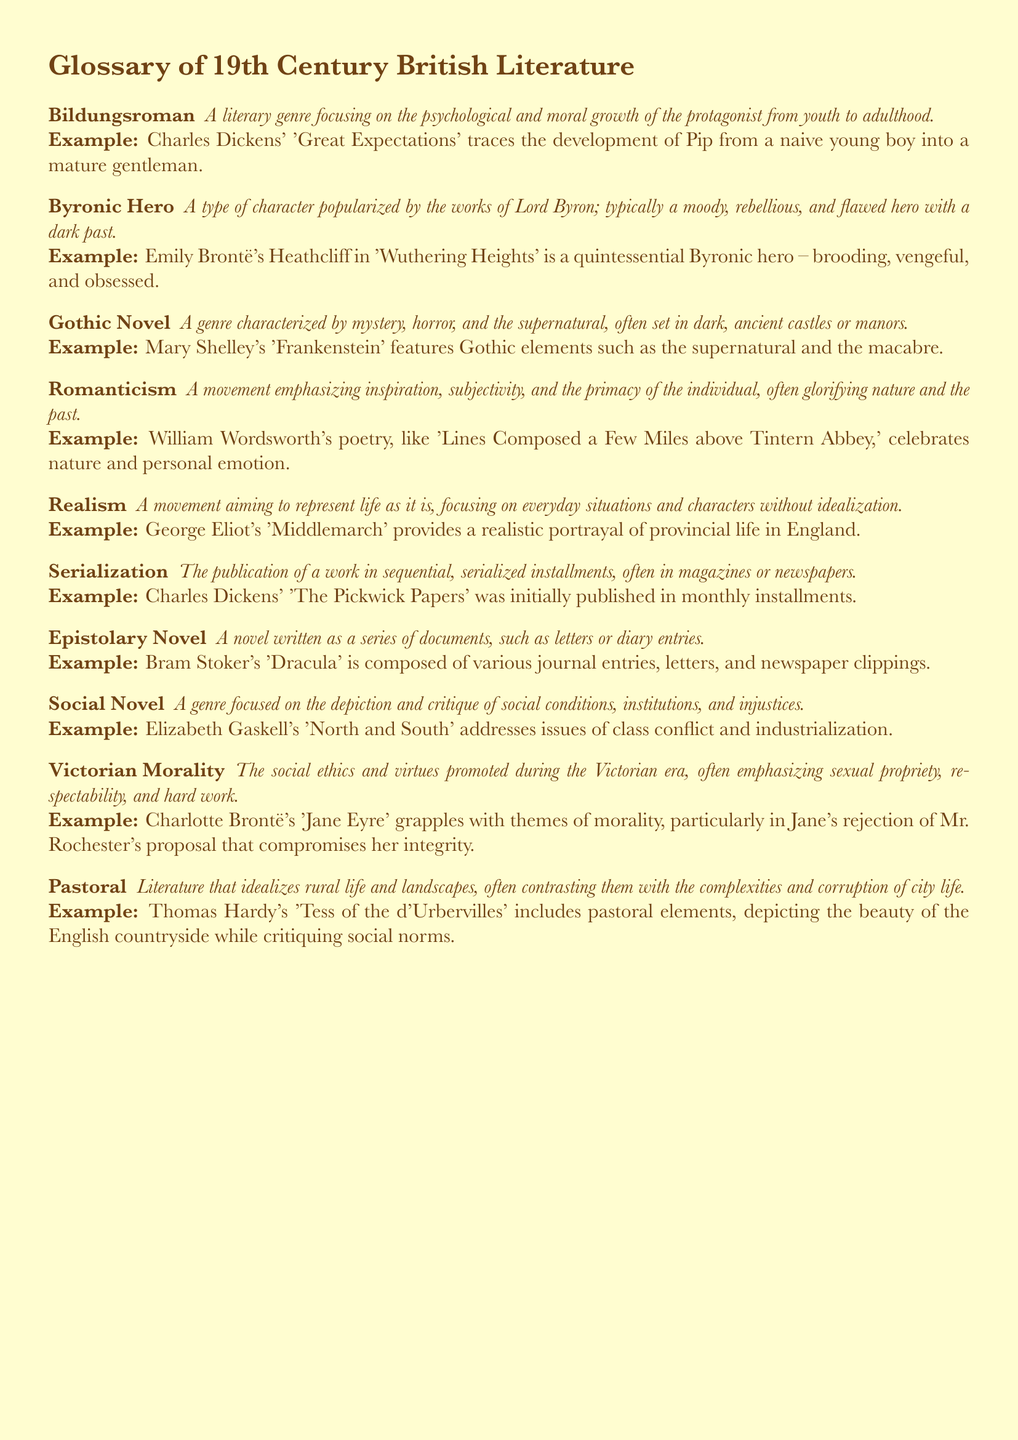What is the first term in the glossary? The first term listed in the glossary is 'Bildungsroman'.
Answer: Bildungsroman What genre does Charles Dickens' 'Great Expectations' represent? 'Great Expectations' is an example of the 'Bildungsroman' genre.
Answer: Bildungsroman Who is a quintessential Byronic hero according to the document? The document states that Heathcliff in 'Wuthering Heights' is a quintessential Byronic hero.
Answer: Heathcliff Which author wrote the novel 'Frankenstein'? The document mentions that Mary Shelley wrote 'Frankenstein'.
Answer: Mary Shelley What literary movement does William Wordsworth's poetry belong to? The document indicates that William Wordsworth's poetry is associated with 'Romanticism'.
Answer: Romanticism What type of novel is 'Dracula' categorized as? The document categorizes 'Dracula' as an 'Epistolary Novel'.
Answer: Epistolary Novel Which social issues are addressed in Elizabeth Gaskell's 'North and South'? The document indicates that 'North and South' addresses issues of class conflict and industrialization.
Answer: Class conflict and industrialization What is the key characteristic of Victorian Morality depicted in 'Jane Eyre'? The key characteristic mentioned in 'Jane Eyre' is morality, especially Jane's integrity.
Answer: Morality How is 'The Pickwick Papers' published? The document states that 'The Pickwick Papers' was published in monthly installments.
Answer: Monthly installments 